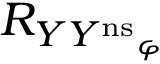Convert formula to latex. <formula><loc_0><loc_0><loc_500><loc_500>R _ { { Y Y ^ { n s } } _ { \varphi } }</formula> 